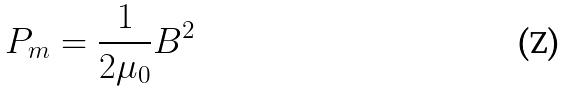Convert formula to latex. <formula><loc_0><loc_0><loc_500><loc_500>P _ { m } = \frac { 1 } { 2 \mu _ { 0 } } B ^ { 2 }</formula> 